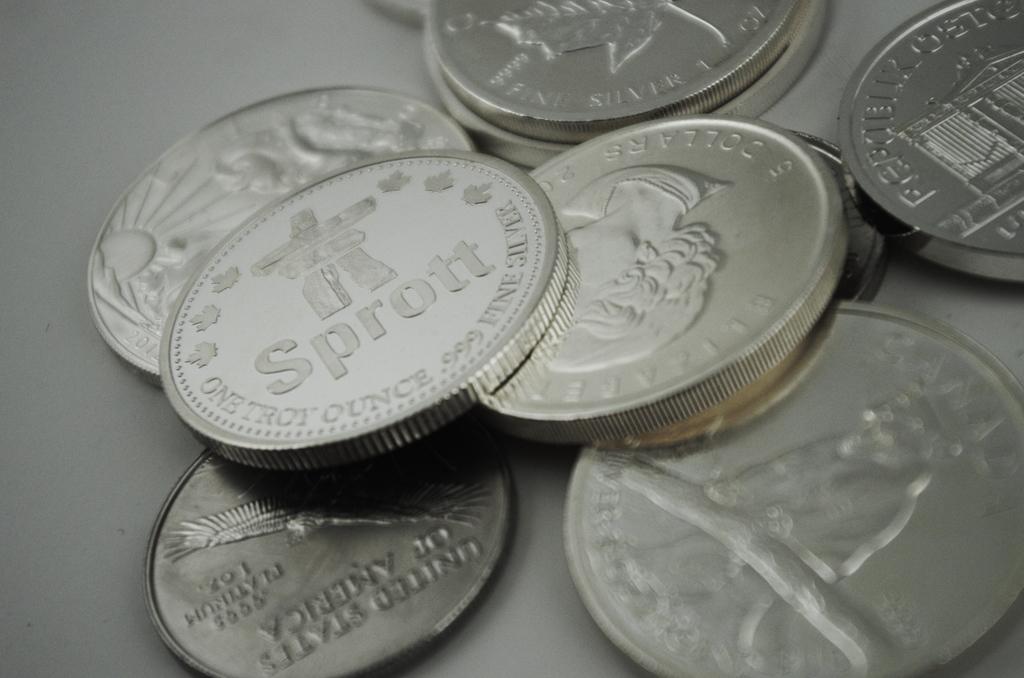How much does the sprott coin weigh in ounces?
Make the answer very short. One troy ounce. What is the name on the coin?
Make the answer very short. Sprott. 